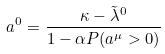Convert formula to latex. <formula><loc_0><loc_0><loc_500><loc_500>a ^ { 0 } = \frac { \kappa - \tilde { \lambda } ^ { 0 } } { 1 - \alpha P ( a ^ { \mu } > 0 ) }</formula> 